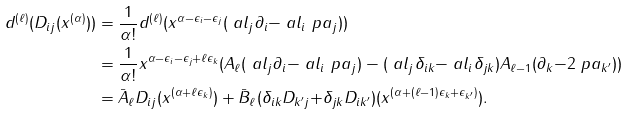<formula> <loc_0><loc_0><loc_500><loc_500>d ^ { ( \ell ) } ( D _ { i j } ( x ^ { ( \alpha ) } ) ) & = \frac { 1 } { \alpha ! } d ^ { ( \ell ) } ( x ^ { \alpha { - } \epsilon _ { i } { - } \epsilon _ { j } } ( \ a l _ { j } \partial _ { i } { - } \ a l _ { i } \ p a _ { j } ) ) \\ & = \frac { 1 } { \alpha ! } x ^ { \alpha { - } \epsilon _ { i } { - } \epsilon _ { j } + \ell \epsilon _ { k } } ( A _ { \ell } ( \ a l _ { j } \partial _ { i } { - } \ a l _ { i } \ p a _ { j } ) - ( \ a l _ { j } \delta _ { i k } { - } \ a l _ { i } \delta _ { j k } ) A _ { \ell { - } 1 } ( \partial _ { k } { - } 2 \ p a _ { k ^ { \prime } } ) ) \\ & = \bar { A } _ { \ell } D _ { i j } ( x ^ { ( \alpha { + } \ell \epsilon _ { k } ) } ) + \bar { B } _ { \ell } ( \delta _ { i k } D _ { k ^ { \prime } j } { + } \delta _ { j k } D _ { i k ^ { \prime } } ) ( x ^ { ( \alpha { + } ( \ell - 1 ) \epsilon _ { k } + \epsilon _ { k ^ { \prime } } ) } ) .</formula> 